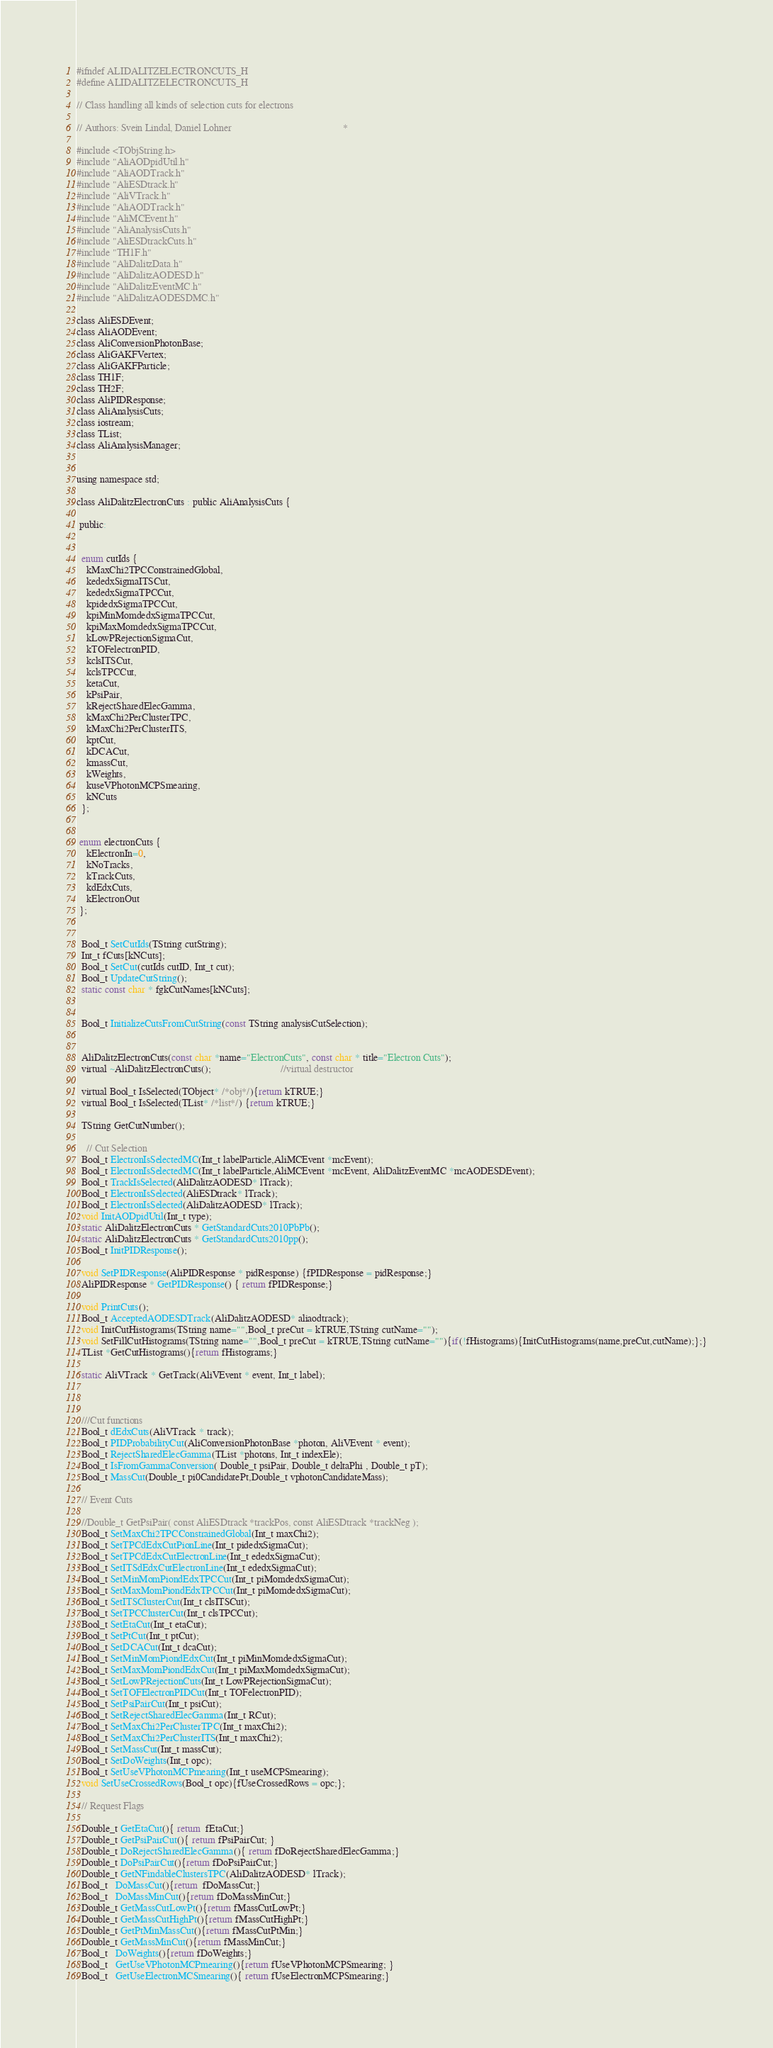Convert code to text. <code><loc_0><loc_0><loc_500><loc_500><_C_>#ifndef ALIDALITZELECTRONCUTS_H
#define ALIDALITZELECTRONCUTS_H

// Class handling all kinds of selection cuts for electrons

// Authors: Svein Lindal, Daniel Lohner												*

#include <TObjString.h>
#include "AliAODpidUtil.h"
#include "AliAODTrack.h"
#include "AliESDtrack.h"
#include "AliVTrack.h"
#include "AliAODTrack.h"
#include "AliMCEvent.h"
#include "AliAnalysisCuts.h"
#include "AliESDtrackCuts.h"
#include "TH1F.h"
#include "AliDalitzData.h"
#include "AliDalitzAODESD.h"
#include "AliDalitzEventMC.h"
#include "AliDalitzAODESDMC.h"

class AliESDEvent;
class AliAODEvent;
class AliConversionPhotonBase;
class AliGAKFVertex;
class AliGAKFParticle;
class TH1F;
class TH2F;
class AliPIDResponse;
class AliAnalysisCuts;
class iostream;
class TList;
class AliAnalysisManager;


using namespace std;

class AliDalitzElectronCuts : public AliAnalysisCuts {

 public:


  enum cutIds {
    kMaxChi2TPCConstrainedGlobal,
    kededxSigmaITSCut,
    kededxSigmaTPCCut,
    kpidedxSigmaTPCCut,
    kpiMinMomdedxSigmaTPCCut,
    kpiMaxMomdedxSigmaTPCCut,
    kLowPRejectionSigmaCut,
    kTOFelectronPID,
    kclsITSCut,
    kclsTPCCut,
    ketaCut,
    kPsiPair,
    kRejectSharedElecGamma,
    kMaxChi2PerClusterTPC,
    kMaxChi2PerClusterITS,
    kptCut,
    kDCACut,
    kmassCut,
    kWeights,
    kuseVPhotonMCPSmearing,
    kNCuts
  };


 enum electronCuts {
    kElectronIn=0,
    kNoTracks,
    kTrackCuts,
    kdEdxCuts,
    kElectronOut
 };


  Bool_t SetCutIds(TString cutString);
  Int_t fCuts[kNCuts];
  Bool_t SetCut(cutIds cutID, Int_t cut);
  Bool_t UpdateCutString();
  static const char * fgkCutNames[kNCuts];


  Bool_t InitializeCutsFromCutString(const TString analysisCutSelection);


  AliDalitzElectronCuts(const char *name="ElectronCuts", const char * title="Electron Cuts");
  virtual ~AliDalitzElectronCuts();                            //virtual destructor

  virtual Bool_t IsSelected(TObject* /*obj*/){return kTRUE;}
  virtual Bool_t IsSelected(TList* /*list*/) {return kTRUE;}

  TString GetCutNumber();

    // Cut Selection
  Bool_t ElectronIsSelectedMC(Int_t labelParticle,AliMCEvent *mcEvent);
  Bool_t ElectronIsSelectedMC(Int_t labelParticle,AliMCEvent *mcEvent, AliDalitzEventMC *mcAODESDEvent);
  Bool_t TrackIsSelected(AliDalitzAODESD* lTrack);
  Bool_t ElectronIsSelected(AliESDtrack* lTrack);
  Bool_t ElectronIsSelected(AliDalitzAODESD* lTrack);
  void InitAODpidUtil(Int_t type);
  static AliDalitzElectronCuts * GetStandardCuts2010PbPb();
  static AliDalitzElectronCuts * GetStandardCuts2010pp();
  Bool_t InitPIDResponse();

  void SetPIDResponse(AliPIDResponse * pidResponse) {fPIDResponse = pidResponse;}
  AliPIDResponse * GetPIDResponse() { return fPIDResponse;}

  void PrintCuts();
  Bool_t AcceptedAODESDTrack(AliDalitzAODESD* aliaodtrack);
  void InitCutHistograms(TString name="",Bool_t preCut = kTRUE,TString cutName="");
  void SetFillCutHistograms(TString name="",Bool_t preCut = kTRUE,TString cutName=""){if(!fHistograms){InitCutHistograms(name,preCut,cutName);};}
  TList *GetCutHistograms(){return fHistograms;}

  static AliVTrack * GetTrack(AliVEvent * event, Int_t label);



  ///Cut functions
  Bool_t dEdxCuts(AliVTrack * track);
  Bool_t PIDProbabilityCut(AliConversionPhotonBase *photon, AliVEvent * event);
  Bool_t RejectSharedElecGamma(TList *photons, Int_t indexEle);
  Bool_t IsFromGammaConversion( Double_t psiPair, Double_t deltaPhi , Double_t pT);
  Bool_t MassCut(Double_t pi0CandidatePt,Double_t vphotonCandidateMass);

  // Event Cuts

  //Double_t GetPsiPair( const AliESDtrack *trackPos, const AliESDtrack *trackNeg );
  Bool_t SetMaxChi2TPCConstrainedGlobal(Int_t maxChi2);
  Bool_t SetTPCdEdxCutPionLine(Int_t pidedxSigmaCut);
  Bool_t SetTPCdEdxCutElectronLine(Int_t ededxSigmaCut);
  Bool_t SetITSdEdxCutElectronLine(Int_t ededxSigmaCut);
  Bool_t SetMinMomPiondEdxTPCCut(Int_t piMomdedxSigmaCut);
  Bool_t SetMaxMomPiondEdxTPCCut(Int_t piMomdedxSigmaCut);
  Bool_t SetITSClusterCut(Int_t clsITSCut);
  Bool_t SetTPCClusterCut(Int_t clsTPCCut);
  Bool_t SetEtaCut(Int_t etaCut);
  Bool_t SetPtCut(Int_t ptCut);
  Bool_t SetDCACut(Int_t dcaCut);
  Bool_t SetMinMomPiondEdxCut(Int_t piMinMomdedxSigmaCut);
  Bool_t SetMaxMomPiondEdxCut(Int_t piMaxMomdedxSigmaCut);
  Bool_t SetLowPRejectionCuts(Int_t LowPRejectionSigmaCut);
  Bool_t SetTOFElectronPIDCut(Int_t TOFelectronPID);
  Bool_t SetPsiPairCut(Int_t psiCut);
  Bool_t SetRejectSharedElecGamma(Int_t RCut);
  Bool_t SetMaxChi2PerClusterTPC(Int_t maxChi2);
  Bool_t SetMaxChi2PerClusterITS(Int_t maxChi2);
  Bool_t SetMassCut(Int_t massCut);
  Bool_t SetDoWeights(Int_t opc);
  Bool_t SetUseVPhotonMCPmearing(Int_t useMCPSmearing);
  void SetUseCrossedRows(Bool_t opc){fUseCrossedRows = opc;};

  // Request Flags

  Double_t GetEtaCut(){ return  fEtaCut;}
  Double_t GetPsiPairCut(){ return fPsiPairCut; }
  Double_t DoRejectSharedElecGamma(){ return fDoRejectSharedElecGamma;}
  Double_t DoPsiPairCut(){return fDoPsiPairCut;}
  Double_t GetNFindableClustersTPC(AliDalitzAODESD* lTrack);
  Bool_t   DoMassCut(){return  fDoMassCut;}
  Bool_t   DoMassMinCut(){return fDoMassMinCut;}
  Double_t GetMassCutLowPt(){return fMassCutLowPt;}
  Double_t GetMassCutHighPt(){return fMassCutHighPt;}
  Double_t GetPtMinMassCut(){return fMassCutPtMin;}
  Double_t GetMassMinCut(){return fMassMinCut;}
  Bool_t   DoWeights(){return fDoWeights;}
  Bool_t   GetUseVPhotonMCPmearing(){return fUseVPhotonMCPSmearing; }
  Bool_t   GetUseElectronMCSmearing(){ return fUseElectronMCPSmearing;}
</code> 